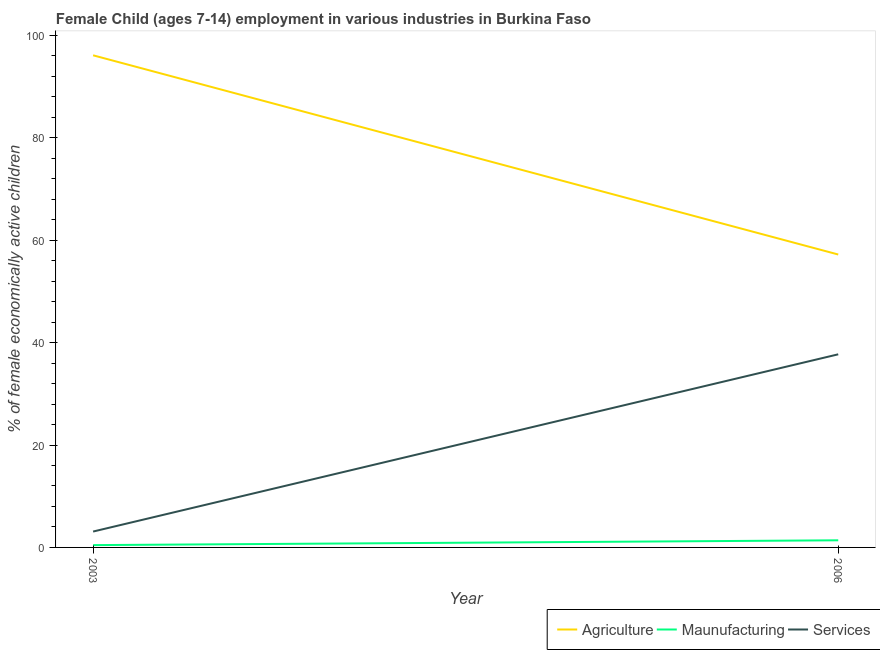How many different coloured lines are there?
Keep it short and to the point. 3. Is the number of lines equal to the number of legend labels?
Offer a very short reply. Yes. What is the percentage of economically active children in agriculture in 2003?
Make the answer very short. 96.1. Across all years, what is the maximum percentage of economically active children in services?
Keep it short and to the point. 37.71. In which year was the percentage of economically active children in services minimum?
Provide a short and direct response. 2003. What is the total percentage of economically active children in agriculture in the graph?
Make the answer very short. 153.3. What is the difference between the percentage of economically active children in agriculture in 2003 and that in 2006?
Provide a short and direct response. 38.9. What is the difference between the percentage of economically active children in manufacturing in 2006 and the percentage of economically active children in agriculture in 2003?
Provide a succinct answer. -94.71. What is the average percentage of economically active children in manufacturing per year?
Offer a terse response. 0.92. In the year 2006, what is the difference between the percentage of economically active children in services and percentage of economically active children in manufacturing?
Ensure brevity in your answer.  36.32. In how many years, is the percentage of economically active children in manufacturing greater than 64 %?
Your answer should be very brief. 0. What is the ratio of the percentage of economically active children in agriculture in 2003 to that in 2006?
Give a very brief answer. 1.68. Is it the case that in every year, the sum of the percentage of economically active children in agriculture and percentage of economically active children in manufacturing is greater than the percentage of economically active children in services?
Offer a very short reply. Yes. How many years are there in the graph?
Keep it short and to the point. 2. What is the difference between two consecutive major ticks on the Y-axis?
Offer a very short reply. 20. Are the values on the major ticks of Y-axis written in scientific E-notation?
Offer a very short reply. No. Does the graph contain any zero values?
Provide a succinct answer. No. Where does the legend appear in the graph?
Provide a short and direct response. Bottom right. How many legend labels are there?
Provide a succinct answer. 3. How are the legend labels stacked?
Give a very brief answer. Horizontal. What is the title of the graph?
Provide a short and direct response. Female Child (ages 7-14) employment in various industries in Burkina Faso. Does "Profit Tax" appear as one of the legend labels in the graph?
Your answer should be compact. No. What is the label or title of the Y-axis?
Your answer should be very brief. % of female economically active children. What is the % of female economically active children in Agriculture in 2003?
Keep it short and to the point. 96.1. What is the % of female economically active children in Maunufacturing in 2003?
Your response must be concise. 0.45. What is the % of female economically active children of Services in 2003?
Keep it short and to the point. 3.1. What is the % of female economically active children of Agriculture in 2006?
Provide a succinct answer. 57.2. What is the % of female economically active children in Maunufacturing in 2006?
Provide a succinct answer. 1.39. What is the % of female economically active children in Services in 2006?
Make the answer very short. 37.71. Across all years, what is the maximum % of female economically active children in Agriculture?
Offer a terse response. 96.1. Across all years, what is the maximum % of female economically active children in Maunufacturing?
Offer a terse response. 1.39. Across all years, what is the maximum % of female economically active children in Services?
Ensure brevity in your answer.  37.71. Across all years, what is the minimum % of female economically active children of Agriculture?
Give a very brief answer. 57.2. Across all years, what is the minimum % of female economically active children of Maunufacturing?
Offer a very short reply. 0.45. What is the total % of female economically active children of Agriculture in the graph?
Your response must be concise. 153.3. What is the total % of female economically active children in Maunufacturing in the graph?
Your answer should be compact. 1.84. What is the total % of female economically active children in Services in the graph?
Provide a succinct answer. 40.81. What is the difference between the % of female economically active children of Agriculture in 2003 and that in 2006?
Your answer should be very brief. 38.9. What is the difference between the % of female economically active children in Maunufacturing in 2003 and that in 2006?
Offer a terse response. -0.94. What is the difference between the % of female economically active children in Services in 2003 and that in 2006?
Give a very brief answer. -34.61. What is the difference between the % of female economically active children of Agriculture in 2003 and the % of female economically active children of Maunufacturing in 2006?
Your answer should be compact. 94.71. What is the difference between the % of female economically active children of Agriculture in 2003 and the % of female economically active children of Services in 2006?
Give a very brief answer. 58.39. What is the difference between the % of female economically active children in Maunufacturing in 2003 and the % of female economically active children in Services in 2006?
Give a very brief answer. -37.26. What is the average % of female economically active children in Agriculture per year?
Provide a short and direct response. 76.65. What is the average % of female economically active children in Maunufacturing per year?
Offer a very short reply. 0.92. What is the average % of female economically active children in Services per year?
Keep it short and to the point. 20.41. In the year 2003, what is the difference between the % of female economically active children of Agriculture and % of female economically active children of Maunufacturing?
Your response must be concise. 95.65. In the year 2003, what is the difference between the % of female economically active children in Agriculture and % of female economically active children in Services?
Make the answer very short. 93. In the year 2003, what is the difference between the % of female economically active children in Maunufacturing and % of female economically active children in Services?
Make the answer very short. -2.65. In the year 2006, what is the difference between the % of female economically active children in Agriculture and % of female economically active children in Maunufacturing?
Ensure brevity in your answer.  55.81. In the year 2006, what is the difference between the % of female economically active children of Agriculture and % of female economically active children of Services?
Your answer should be very brief. 19.49. In the year 2006, what is the difference between the % of female economically active children of Maunufacturing and % of female economically active children of Services?
Give a very brief answer. -36.32. What is the ratio of the % of female economically active children of Agriculture in 2003 to that in 2006?
Your answer should be compact. 1.68. What is the ratio of the % of female economically active children in Maunufacturing in 2003 to that in 2006?
Your answer should be compact. 0.32. What is the ratio of the % of female economically active children of Services in 2003 to that in 2006?
Offer a very short reply. 0.08. What is the difference between the highest and the second highest % of female economically active children of Agriculture?
Offer a terse response. 38.9. What is the difference between the highest and the second highest % of female economically active children in Maunufacturing?
Offer a very short reply. 0.94. What is the difference between the highest and the second highest % of female economically active children in Services?
Your answer should be very brief. 34.61. What is the difference between the highest and the lowest % of female economically active children in Agriculture?
Provide a short and direct response. 38.9. What is the difference between the highest and the lowest % of female economically active children of Maunufacturing?
Keep it short and to the point. 0.94. What is the difference between the highest and the lowest % of female economically active children of Services?
Your response must be concise. 34.61. 